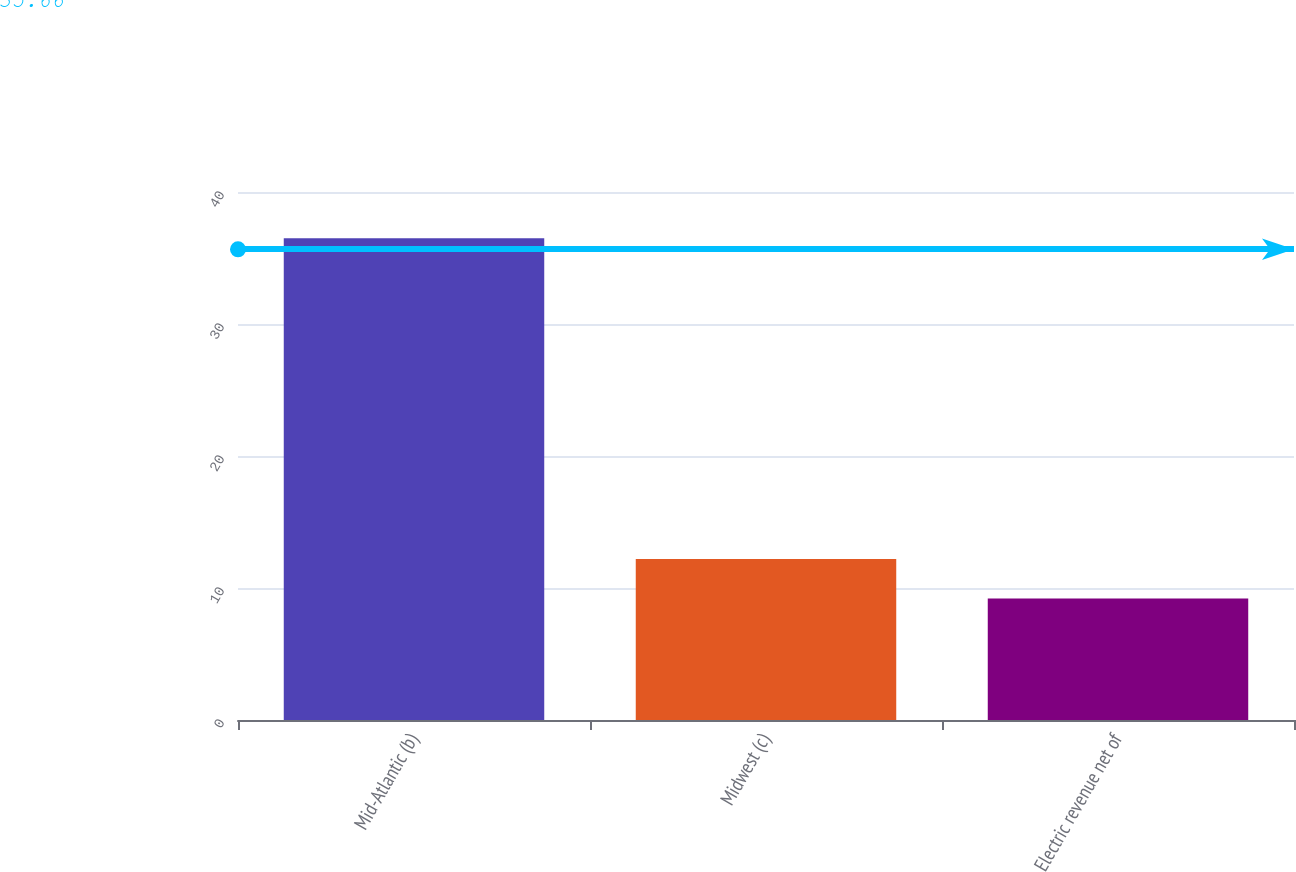<chart> <loc_0><loc_0><loc_500><loc_500><bar_chart><fcel>Mid-Atlantic (b)<fcel>Midwest (c)<fcel>Electric revenue net of<nl><fcel>36.5<fcel>12.2<fcel>9.2<nl></chart> 